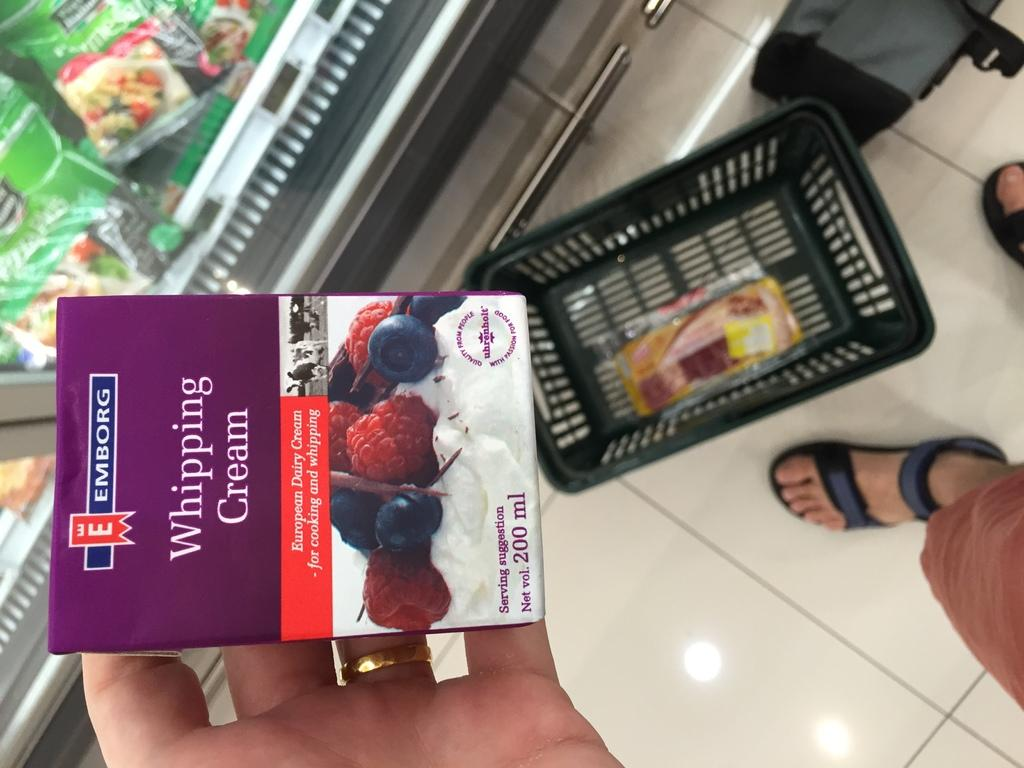Provide a one-sentence caption for the provided image. A box of Emborg Whipping cream taken in a super market. 